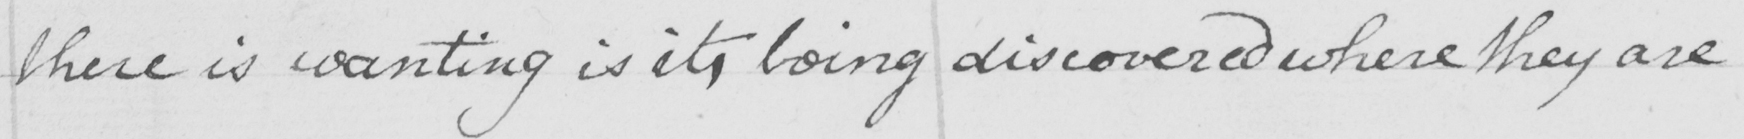What does this handwritten line say? there is wanting is it , being discovered where they are 